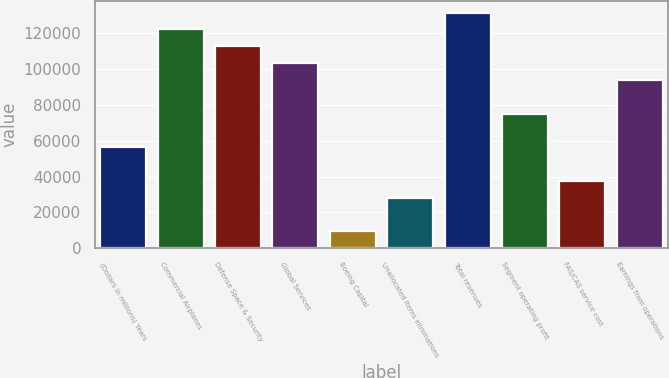Convert chart to OTSL. <chart><loc_0><loc_0><loc_500><loc_500><bar_chart><fcel>(Dollars in millions) Years<fcel>Commercial Airplanes<fcel>Defense Space & Security<fcel>Global Services<fcel>Boeing Capital<fcel>Unallocated items eliminations<fcel>Total revenues<fcel>Segment operating profit<fcel>FAS/CAS service cost<fcel>Earnings from operations<nl><fcel>56452.2<fcel>122170<fcel>112781<fcel>103393<fcel>9511.2<fcel>28287.6<fcel>131558<fcel>75228.6<fcel>37675.8<fcel>94005<nl></chart> 